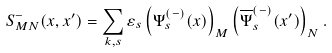<formula> <loc_0><loc_0><loc_500><loc_500>S ^ { - } _ { M N } ( x , x ^ { \prime } ) = \sum _ { k , s } \varepsilon _ { s } \left ( \Psi ^ { ( - ) } _ { s } ( x ) \right ) _ { M } \left ( \overline { \Psi } ^ { ( - ) } _ { s } ( x ^ { \prime } ) \right ) _ { N } .</formula> 